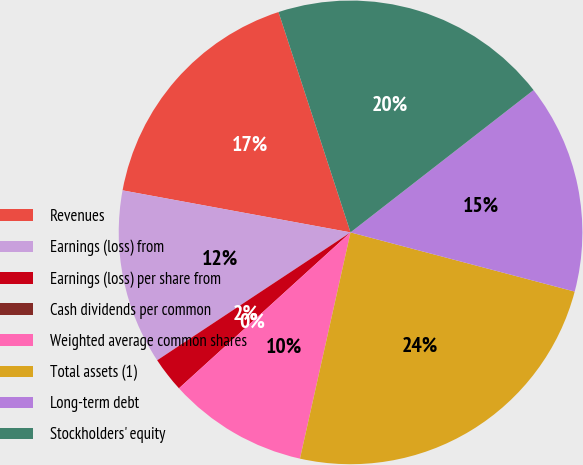<chart> <loc_0><loc_0><loc_500><loc_500><pie_chart><fcel>Revenues<fcel>Earnings (loss) from<fcel>Earnings (loss) per share from<fcel>Cash dividends per common<fcel>Weighted average common shares<fcel>Total assets (1)<fcel>Long-term debt<fcel>Stockholders' equity<nl><fcel>17.07%<fcel>12.2%<fcel>2.44%<fcel>0.0%<fcel>9.76%<fcel>24.39%<fcel>14.63%<fcel>19.51%<nl></chart> 